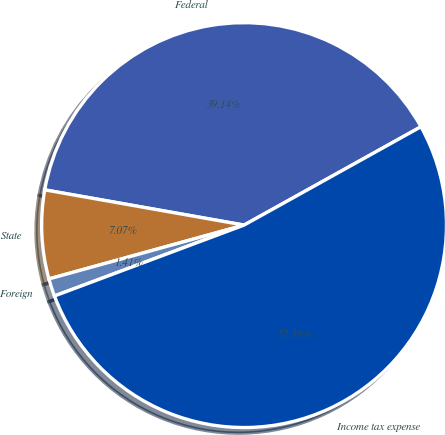Convert chart. <chart><loc_0><loc_0><loc_500><loc_500><pie_chart><fcel>Federal<fcel>State<fcel>Foreign<fcel>Income tax expense<nl><fcel>39.14%<fcel>7.07%<fcel>1.41%<fcel>52.38%<nl></chart> 